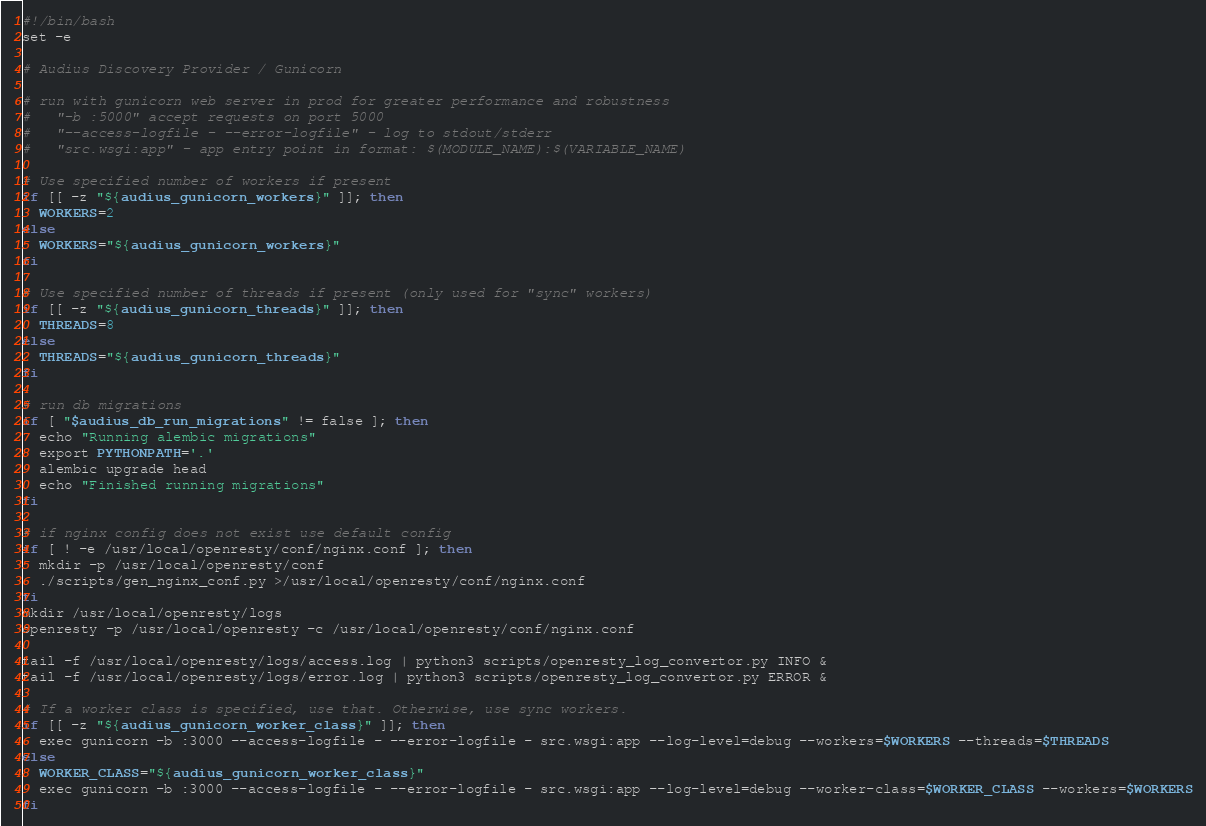<code> <loc_0><loc_0><loc_500><loc_500><_Bash_>#!/bin/bash
set -e

# Audius Discovery Provider / Gunicorn

# run with gunicorn web server in prod for greater performance and robustness
#   "-b :5000" accept requests on port 5000
#   "--access-logfile - --error-logfile" - log to stdout/stderr
#   "src.wsgi:app" - app entry point in format: $(MODULE_NAME):$(VARIABLE_NAME)

# Use specified number of workers if present
if [[ -z "${audius_gunicorn_workers}" ]]; then
  WORKERS=2
else
  WORKERS="${audius_gunicorn_workers}"
fi

# Use specified number of threads if present (only used for "sync" workers)
if [[ -z "${audius_gunicorn_threads}" ]]; then
  THREADS=8
else
  THREADS="${audius_gunicorn_threads}"
fi

# run db migrations
if [ "$audius_db_run_migrations" != false ]; then
  echo "Running alembic migrations"
  export PYTHONPATH='.'
  alembic upgrade head
  echo "Finished running migrations"
fi

# if nginx config does not exist use default config
if [ ! -e /usr/local/openresty/conf/nginx.conf ]; then
  mkdir -p /usr/local/openresty/conf
  ./scripts/gen_nginx_conf.py >/usr/local/openresty/conf/nginx.conf
fi
mkdir /usr/local/openresty/logs
openresty -p /usr/local/openresty -c /usr/local/openresty/conf/nginx.conf

tail -f /usr/local/openresty/logs/access.log | python3 scripts/openresty_log_convertor.py INFO &
tail -f /usr/local/openresty/logs/error.log | python3 scripts/openresty_log_convertor.py ERROR &

# If a worker class is specified, use that. Otherwise, use sync workers.
if [[ -z "${audius_gunicorn_worker_class}" ]]; then
  exec gunicorn -b :3000 --access-logfile - --error-logfile - src.wsgi:app --log-level=debug --workers=$WORKERS --threads=$THREADS
else
  WORKER_CLASS="${audius_gunicorn_worker_class}"
  exec gunicorn -b :3000 --access-logfile - --error-logfile - src.wsgi:app --log-level=debug --worker-class=$WORKER_CLASS --workers=$WORKERS
fi
</code> 